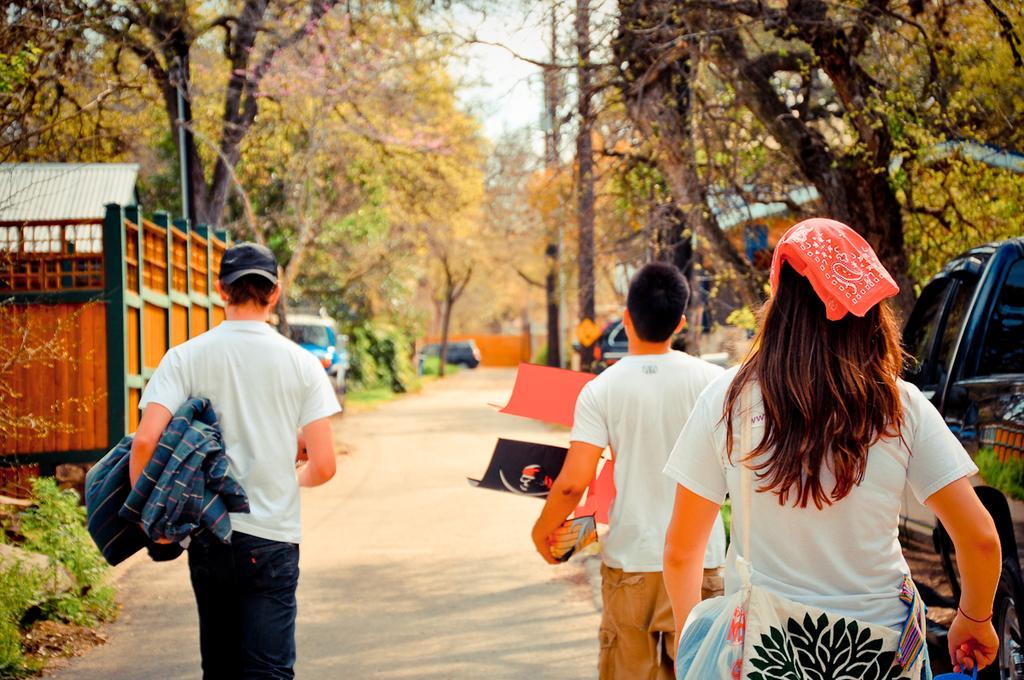In one or two sentences, can you explain what this image depicts? In this image I can see three persons walking on the road. The person in front wearing white shirt, black color pant. Background I can see few vehicles on the road, trees in green color and the sky is in white color. 